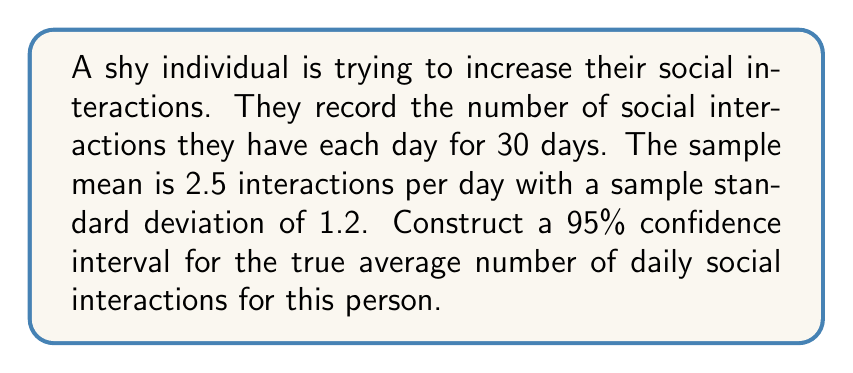What is the answer to this math problem? To construct a 95% confidence interval, we'll follow these steps:

1) The formula for the confidence interval is:

   $$\bar{x} \pm t_{\alpha/2, n-1} \cdot \frac{s}{\sqrt{n}}$$

   Where:
   $\bar{x}$ is the sample mean
   $t_{\alpha/2, n-1}$ is the t-value for a 95% confidence level with n-1 degrees of freedom
   $s$ is the sample standard deviation
   $n$ is the sample size

2) We know:
   $\bar{x} = 2.5$
   $s = 1.2$
   $n = 30$
   Confidence level = 95%, so $\alpha = 0.05$

3) For a 95% confidence interval with 29 degrees of freedom (30 - 1), the t-value is approximately 2.045 (from t-distribution table).

4) Now, let's substitute these values into our formula:

   $$2.5 \pm 2.045 \cdot \frac{1.2}{\sqrt{30}}$$

5) Simplify:
   $$2.5 \pm 2.045 \cdot \frac{1.2}{5.477}$$
   $$2.5 \pm 2.045 \cdot 0.219$$
   $$2.5 \pm 0.448$$

6) Therefore, the confidence interval is:
   $$(2.5 - 0.448, 2.5 + 0.448)$$
   $$(2.052, 2.948)$$
Answer: (2.052, 2.948) 